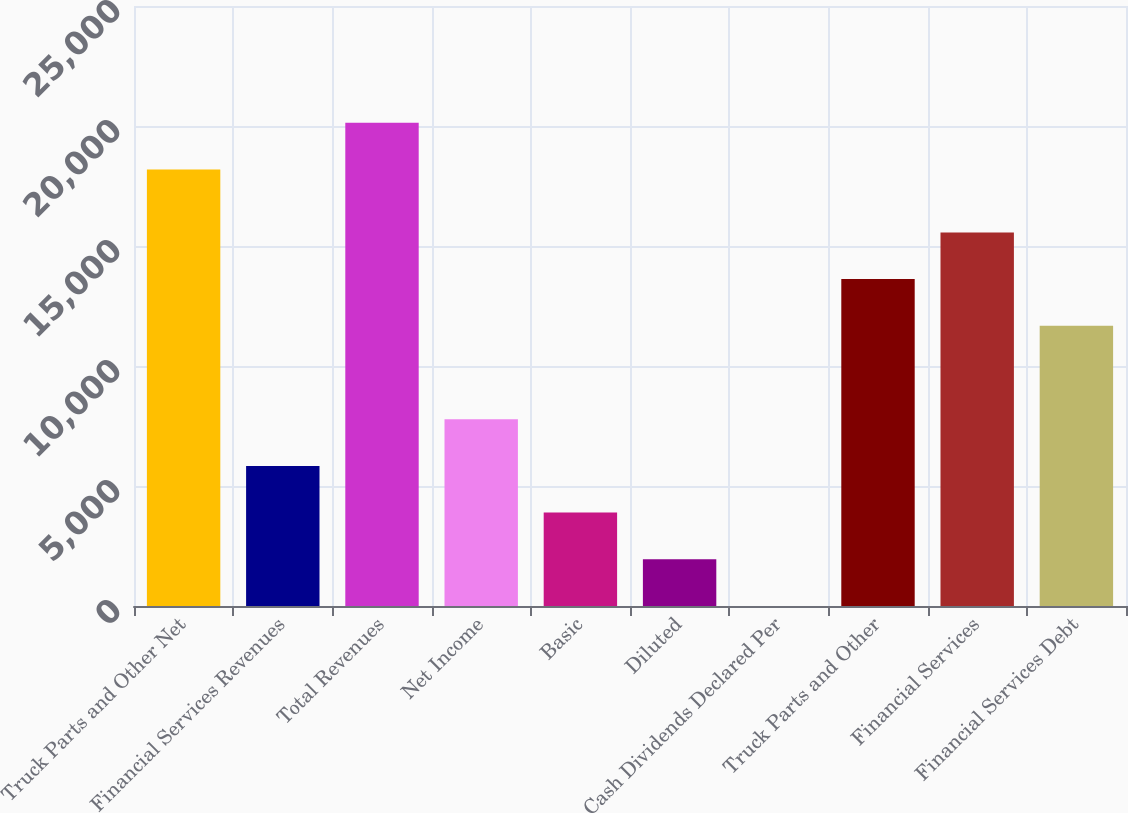Convert chart to OTSL. <chart><loc_0><loc_0><loc_500><loc_500><bar_chart><fcel>Truck Parts and Other Net<fcel>Financial Services Revenues<fcel>Total Revenues<fcel>Net Income<fcel>Basic<fcel>Diluted<fcel>Cash Dividends Declared Per<fcel>Truck Parts and Other<fcel>Financial Services<fcel>Financial Services Debt<nl><fcel>18187.5<fcel>5838.45<fcel>20132.9<fcel>7783.87<fcel>3893.03<fcel>1947.61<fcel>2.19<fcel>13620.1<fcel>15565.5<fcel>11674.7<nl></chart> 